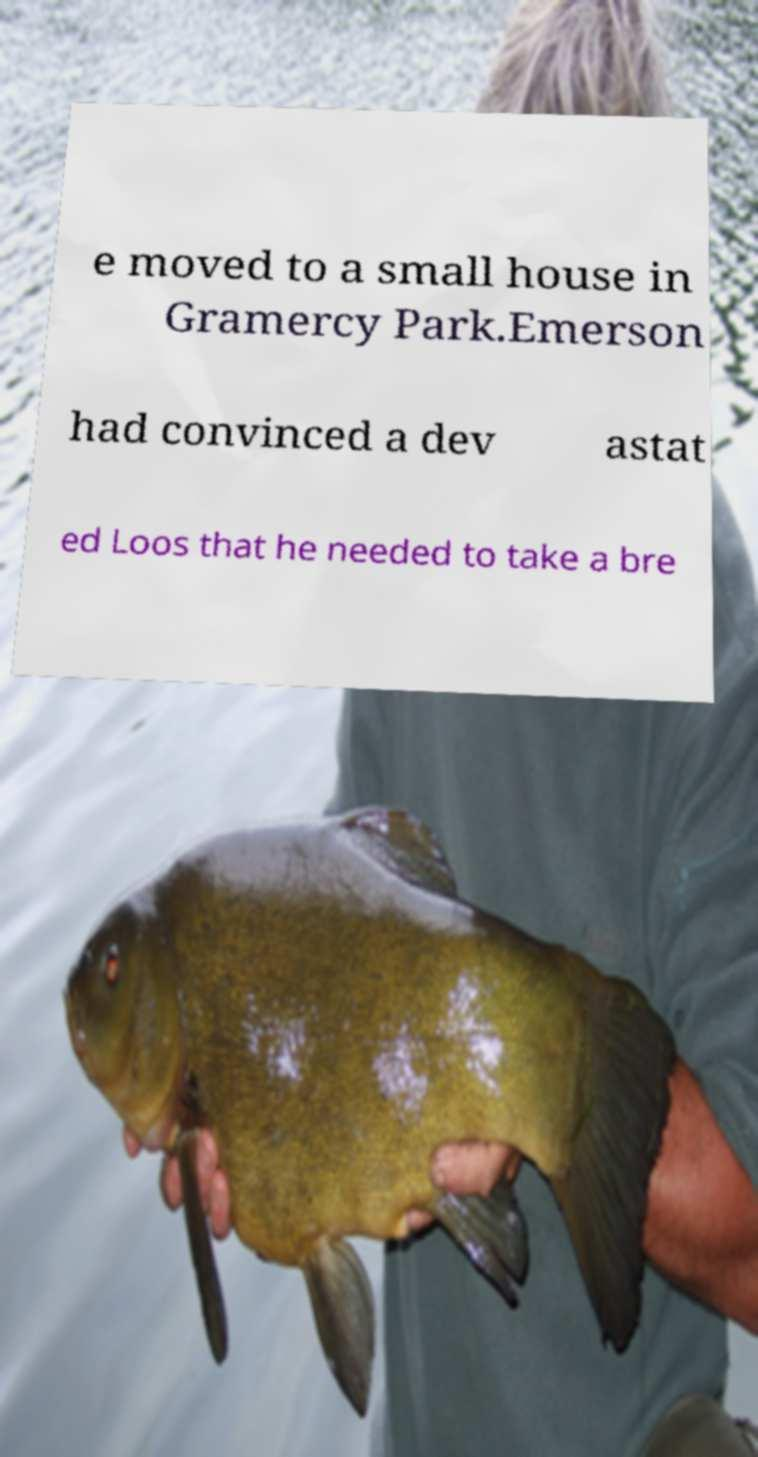Could you assist in decoding the text presented in this image and type it out clearly? e moved to a small house in Gramercy Park.Emerson had convinced a dev astat ed Loos that he needed to take a bre 